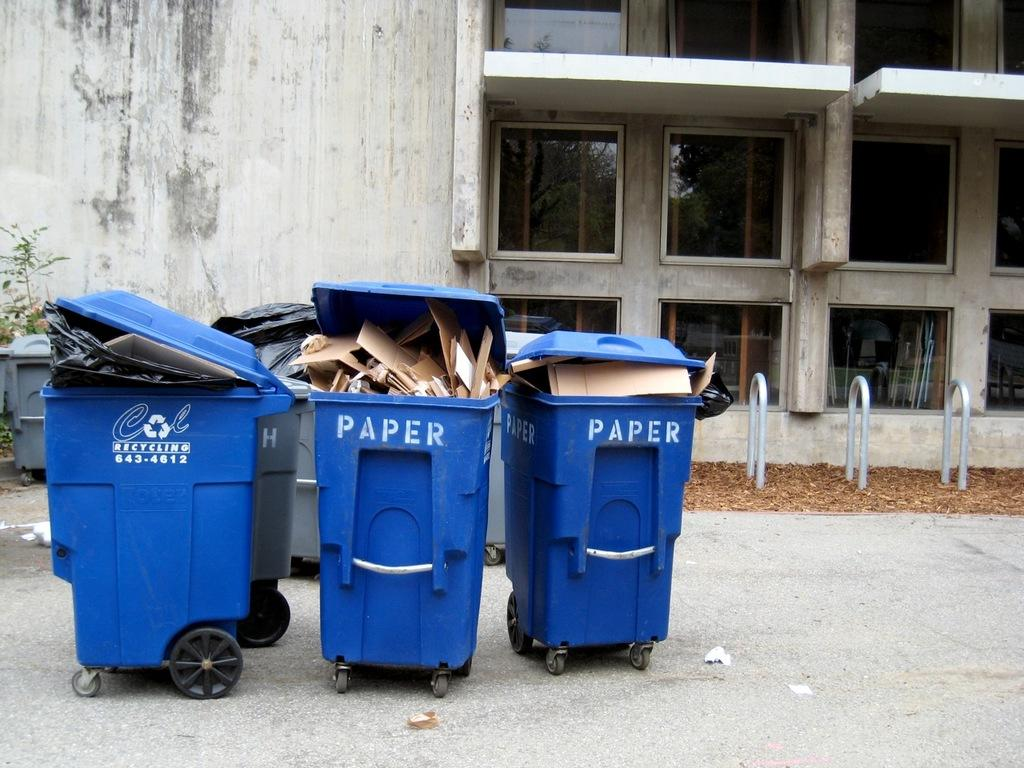<image>
Summarize the visual content of the image. Garbage bins with PAPER written on them are outside of a building. 